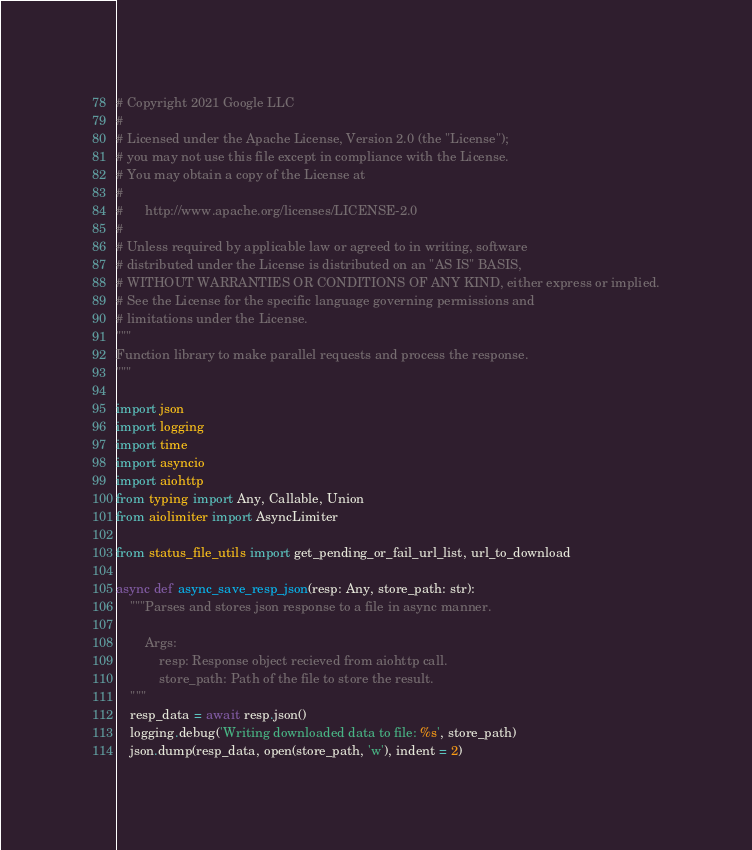<code> <loc_0><loc_0><loc_500><loc_500><_Python_># Copyright 2021 Google LLC
#
# Licensed under the Apache License, Version 2.0 (the "License");
# you may not use this file except in compliance with the License.
# You may obtain a copy of the License at
#
#      http://www.apache.org/licenses/LICENSE-2.0
#
# Unless required by applicable law or agreed to in writing, software
# distributed under the License is distributed on an "AS IS" BASIS,
# WITHOUT WARRANTIES OR CONDITIONS OF ANY KIND, either express or implied.
# See the License for the specific language governing permissions and
# limitations under the License.
"""
Function library to make parallel requests and process the response.
"""

import json
import logging
import time
import asyncio
import aiohttp
from typing import Any, Callable, Union
from aiolimiter import AsyncLimiter

from status_file_utils import get_pending_or_fail_url_list, url_to_download

async def async_save_resp_json(resp: Any, store_path: str):
    """Parses and stores json response to a file in async manner.

        Args:
            resp: Response object recieved from aiohttp call.
            store_path: Path of the file to store the result.
    """
    resp_data = await resp.json()
    logging.debug('Writing downloaded data to file: %s', store_path)
    json.dump(resp_data, open(store_path, 'w'), indent = 2)
</code> 